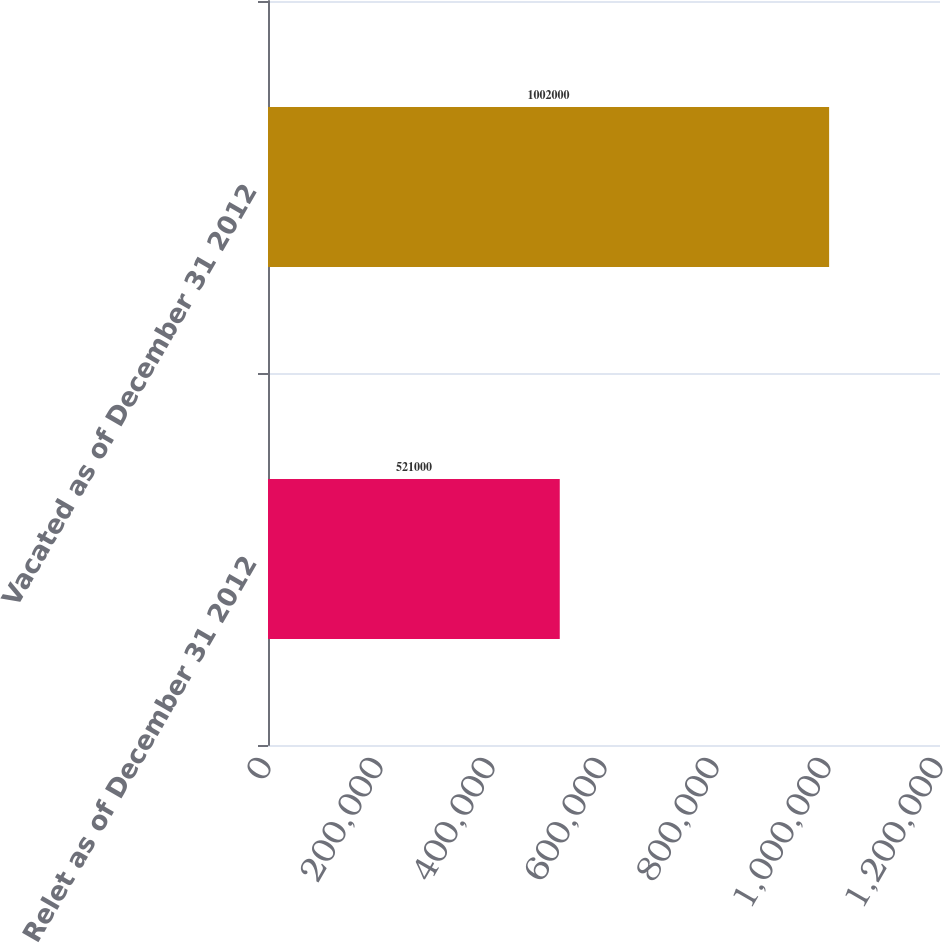Convert chart to OTSL. <chart><loc_0><loc_0><loc_500><loc_500><bar_chart><fcel>Relet as of December 31 2012<fcel>Vacated as of December 31 2012<nl><fcel>521000<fcel>1.002e+06<nl></chart> 